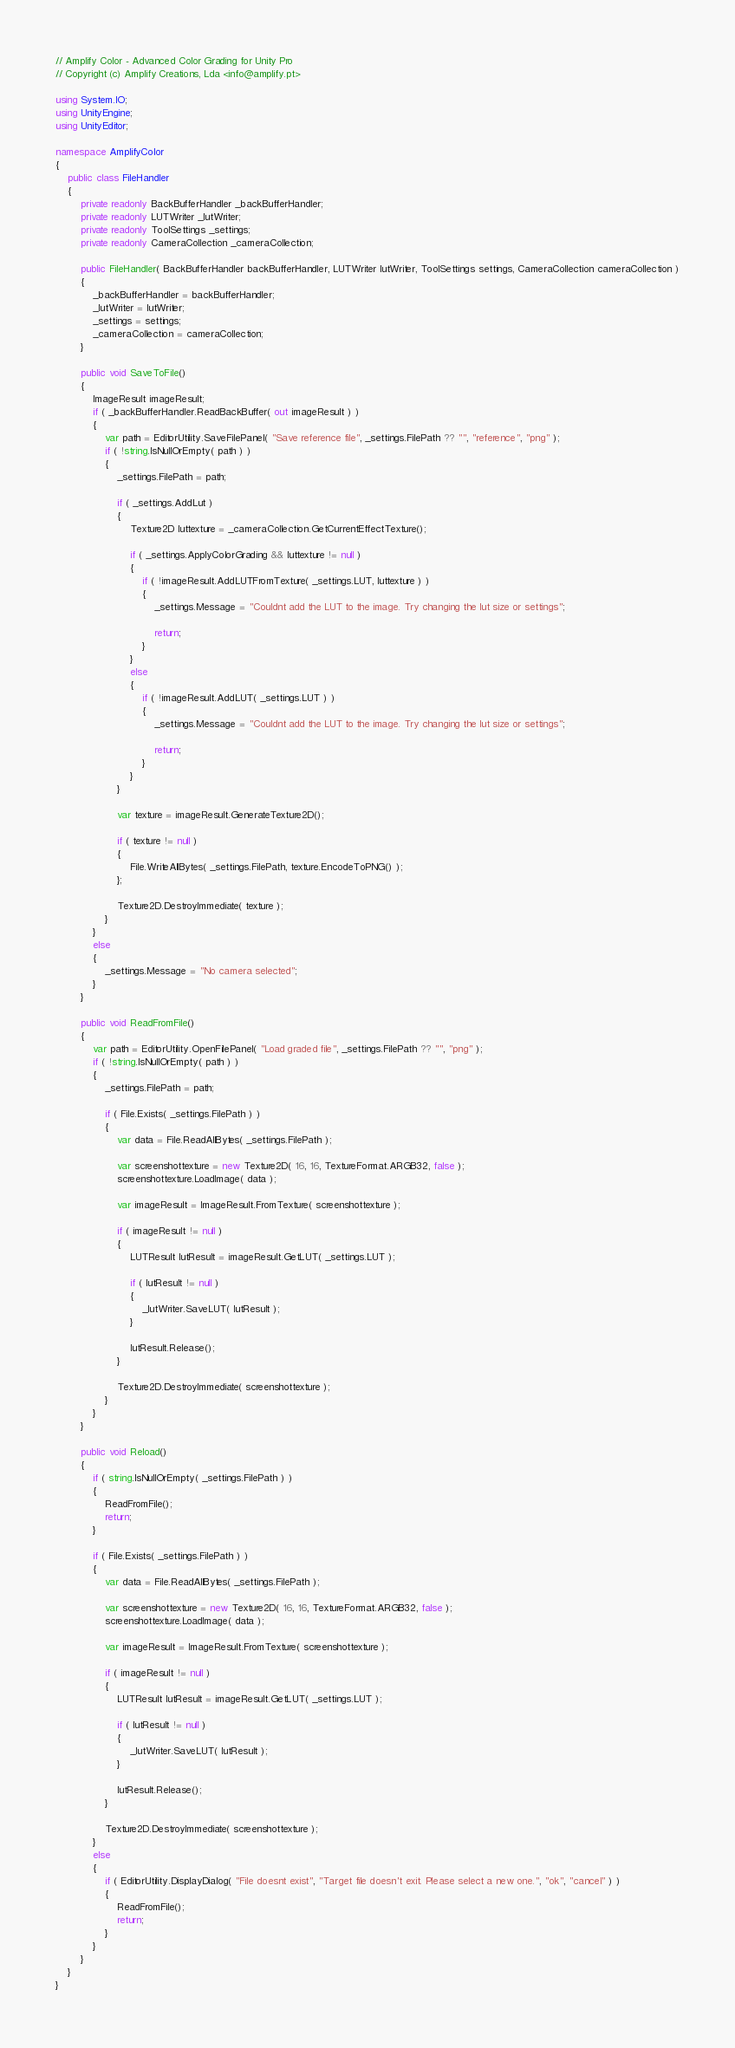Convert code to text. <code><loc_0><loc_0><loc_500><loc_500><_C#_>// Amplify Color - Advanced Color Grading for Unity Pro
// Copyright (c) Amplify Creations, Lda <info@amplify.pt>

using System.IO;
using UnityEngine;
using UnityEditor;

namespace AmplifyColor
{
	public class FileHandler
	{
		private readonly BackBufferHandler _backBufferHandler;
		private readonly LUTWriter _lutWriter;
		private readonly ToolSettings _settings;
		private readonly CameraCollection _cameraCollection;

		public FileHandler( BackBufferHandler backBufferHandler, LUTWriter lutWriter, ToolSettings settings, CameraCollection cameraCollection )
		{
			_backBufferHandler = backBufferHandler;
			_lutWriter = lutWriter;
			_settings = settings;
			_cameraCollection = cameraCollection;
		}

		public void SaveToFile()
		{
			ImageResult imageResult;
			if ( _backBufferHandler.ReadBackBuffer( out imageResult ) )
			{
				var path = EditorUtility.SaveFilePanel( "Save reference file", _settings.FilePath ?? "", "reference", "png" );
				if ( !string.IsNullOrEmpty( path ) )
				{
					_settings.FilePath = path;

					if ( _settings.AddLut )
					{
						Texture2D luttexture = _cameraCollection.GetCurrentEffectTexture();

						if ( _settings.ApplyColorGrading && luttexture != null )
						{
							if ( !imageResult.AddLUTFromTexture( _settings.LUT, luttexture ) )
							{
								_settings.Message = "Couldnt add the LUT to the image. Try changing the lut size or settings";

								return;
							}
						}
						else
						{
							if ( !imageResult.AddLUT( _settings.LUT ) )
							{
								_settings.Message = "Couldnt add the LUT to the image. Try changing the lut size or settings";

								return;
							}
						}
					}

					var texture = imageResult.GenerateTexture2D();

					if ( texture != null )
					{
						File.WriteAllBytes( _settings.FilePath, texture.EncodeToPNG() );
					};

					Texture2D.DestroyImmediate( texture );
				}
			}
			else
			{
				_settings.Message = "No camera selected";
			}
		}

		public void ReadFromFile()
		{
			var path = EditorUtility.OpenFilePanel( "Load graded file", _settings.FilePath ?? "", "png" );
			if ( !string.IsNullOrEmpty( path ) )
			{
				_settings.FilePath = path;

				if ( File.Exists( _settings.FilePath ) )
				{
					var data = File.ReadAllBytes( _settings.FilePath );

					var screenshottexture = new Texture2D( 16, 16, TextureFormat.ARGB32, false );
					screenshottexture.LoadImage( data );

					var imageResult = ImageResult.FromTexture( screenshottexture );

					if ( imageResult != null )
					{
						LUTResult lutResult = imageResult.GetLUT( _settings.LUT );

						if ( lutResult != null )
						{
							_lutWriter.SaveLUT( lutResult );
						}

						lutResult.Release();
					}

					Texture2D.DestroyImmediate( screenshottexture );
				}
			}
		}

		public void Reload()
		{
			if ( string.IsNullOrEmpty( _settings.FilePath ) )
			{
				ReadFromFile();
				return;
			}

			if ( File.Exists( _settings.FilePath ) )
			{
				var data = File.ReadAllBytes( _settings.FilePath );

				var screenshottexture = new Texture2D( 16, 16, TextureFormat.ARGB32, false );
				screenshottexture.LoadImage( data );

				var imageResult = ImageResult.FromTexture( screenshottexture );

				if ( imageResult != null )
				{
					LUTResult lutResult = imageResult.GetLUT( _settings.LUT );

					if ( lutResult != null )
					{
						_lutWriter.SaveLUT( lutResult );
					}

					lutResult.Release();
				}

				Texture2D.DestroyImmediate( screenshottexture );
			}
			else
			{
				if ( EditorUtility.DisplayDialog( "File doesnt exist", "Target file doesn't exit. Please select a new one.", "ok", "cancel" ) )
				{
					ReadFromFile();
					return;
				}
			}
		}
	}
}
</code> 